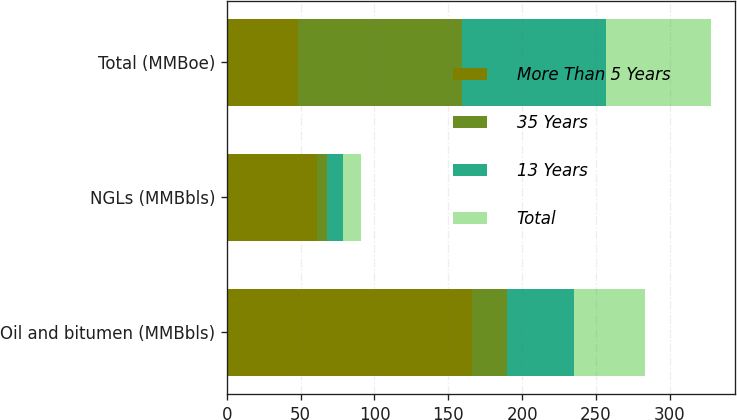Convert chart to OTSL. <chart><loc_0><loc_0><loc_500><loc_500><stacked_bar_chart><ecel><fcel>Oil and bitumen (MMBbls)<fcel>NGLs (MMBbls)<fcel>Total (MMBoe)<nl><fcel>More Than 5 Years<fcel>166<fcel>61<fcel>48<nl><fcel>35 Years<fcel>24<fcel>7<fcel>111<nl><fcel>13 Years<fcel>45<fcel>11<fcel>98<nl><fcel>Total<fcel>48<fcel>12<fcel>71<nl></chart> 